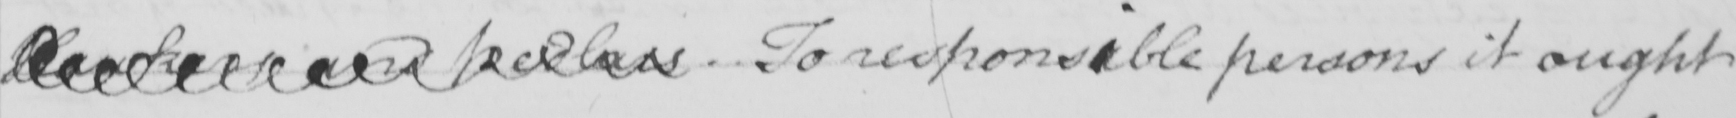Can you tell me what this handwritten text says? Hawkers and Pedlars . To responsible persons it ought 